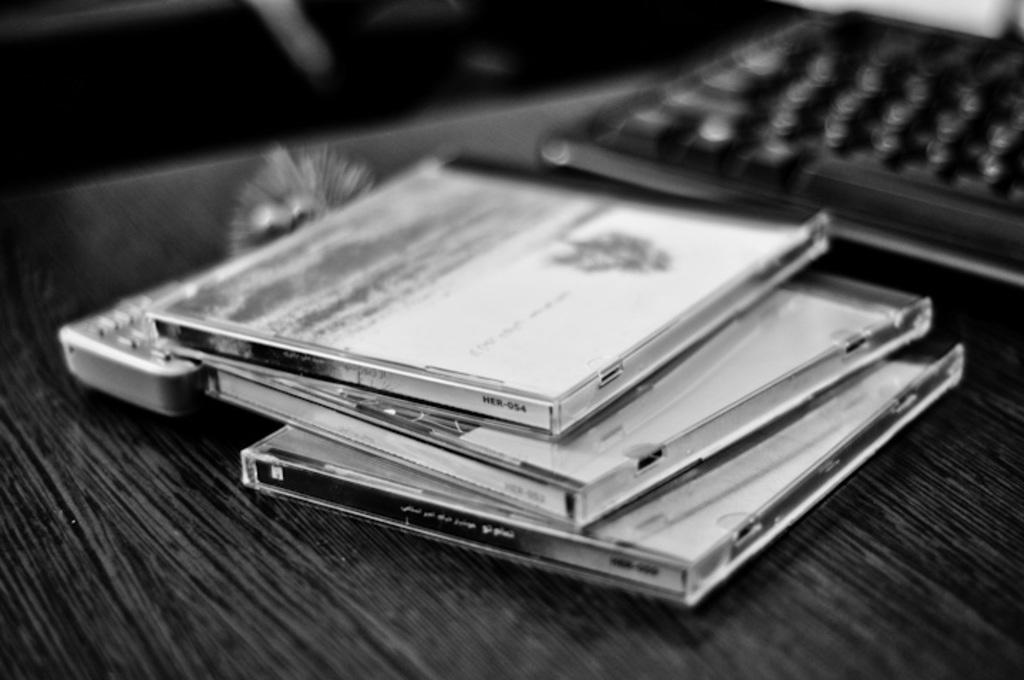<image>
Relay a brief, clear account of the picture shown. A qwerty keyboard sitting on a table next to CD's. 